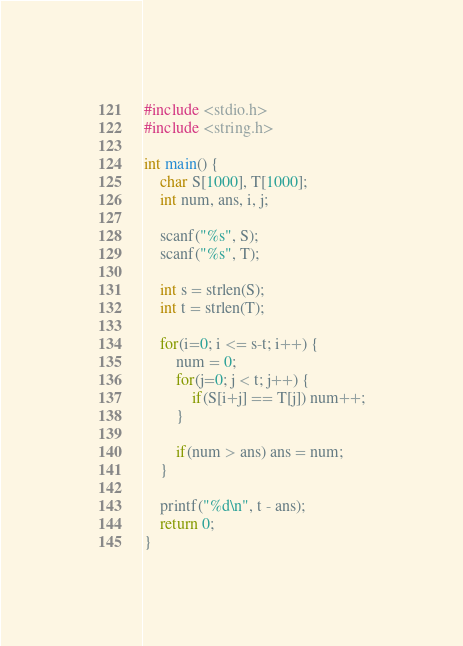<code> <loc_0><loc_0><loc_500><loc_500><_C_>#include <stdio.h>
#include <string.h>

int main() {
    char S[1000], T[1000];
    int num, ans, i, j;

    scanf("%s", S);
    scanf("%s", T);

    int s = strlen(S);
    int t = strlen(T);

    for(i=0; i <= s-t; i++) {
        num = 0;
        for(j=0; j < t; j++) {
            if(S[i+j] == T[j]) num++;
        }

        if(num > ans) ans = num;
    }

    printf("%d\n", t - ans);
    return 0;
}</code> 